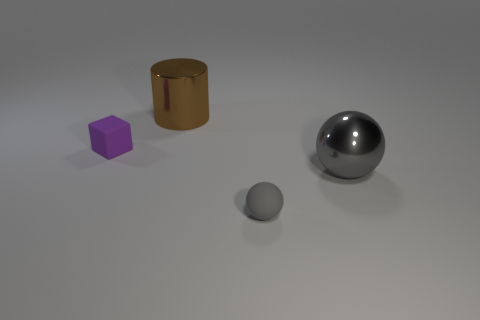Is the number of big brown cylinders that are on the right side of the metallic cylinder less than the number of small red metal cylinders?
Make the answer very short. No. There is a sphere behind the rubber sphere right of the rubber block; what is it made of?
Your answer should be compact. Metal. The thing that is behind the tiny rubber ball and in front of the block has what shape?
Your answer should be compact. Sphere. What number of other objects are the same color as the shiny ball?
Provide a succinct answer. 1. What number of objects are large objects to the left of the big gray metallic sphere or tiny purple shiny cubes?
Make the answer very short. 1. Is the color of the block the same as the rubber object in front of the small purple matte object?
Give a very brief answer. No. How big is the matte object on the right side of the large thing that is behind the purple rubber block?
Offer a very short reply. Small. How many objects are either purple matte things or gray metal things that are on the right side of the large brown shiny cylinder?
Make the answer very short. 2. There is a shiny thing that is behind the tiny block; is it the same shape as the small purple thing?
Your answer should be compact. No. There is a rubber thing to the left of the large metallic thing on the left side of the tiny gray sphere; what number of cubes are in front of it?
Make the answer very short. 0. 